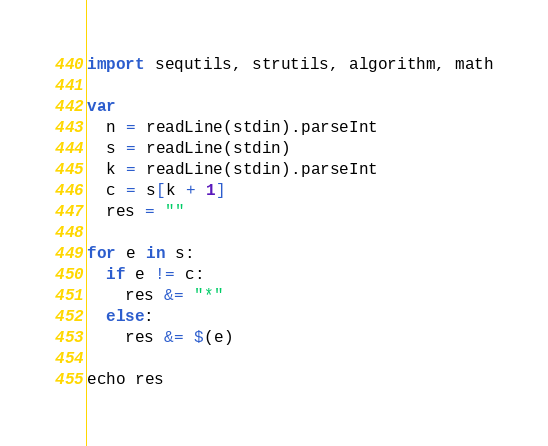Convert code to text. <code><loc_0><loc_0><loc_500><loc_500><_Nim_>import sequtils, strutils, algorithm, math

var
  n = readLine(stdin).parseInt
  s = readLine(stdin)
  k = readLine(stdin).parseInt
  c = s[k + 1]
  res = ""

for e in s:
  if e != c:
    res &= "*"
  else:
    res &= $(e)

echo res</code> 